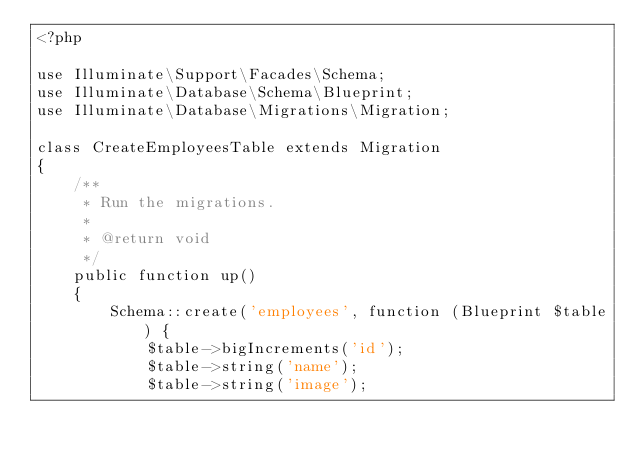<code> <loc_0><loc_0><loc_500><loc_500><_PHP_><?php

use Illuminate\Support\Facades\Schema;
use Illuminate\Database\Schema\Blueprint;
use Illuminate\Database\Migrations\Migration;

class CreateEmployeesTable extends Migration
{
    /**
     * Run the migrations.
     *
     * @return void
     */
    public function up()
    {
        Schema::create('employees', function (Blueprint $table) {
            $table->bigIncrements('id');
            $table->string('name');
            $table->string('image');</code> 